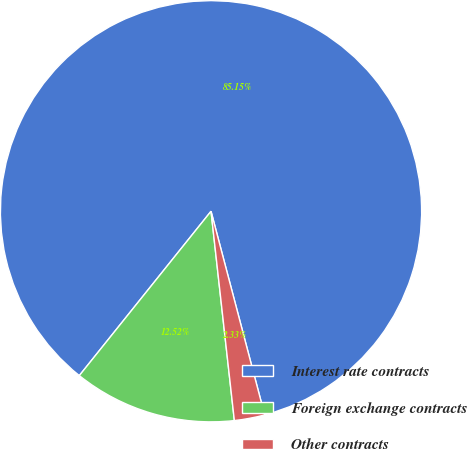Convert chart. <chart><loc_0><loc_0><loc_500><loc_500><pie_chart><fcel>Interest rate contracts<fcel>Foreign exchange contracts<fcel>Other contracts<nl><fcel>85.14%<fcel>12.52%<fcel>2.33%<nl></chart> 